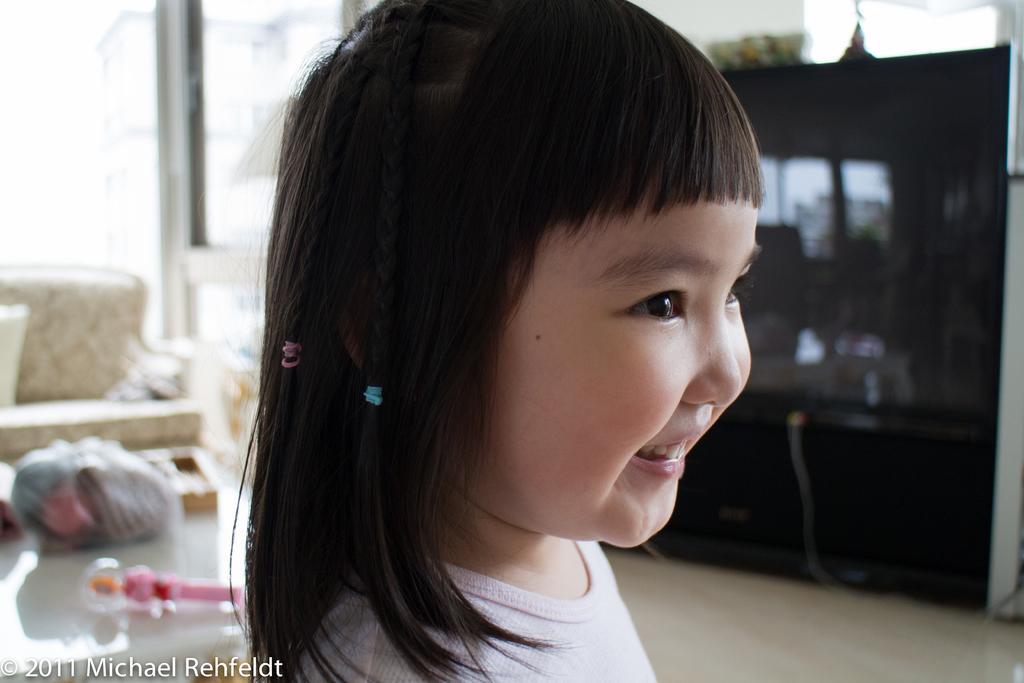Who is the main subject in the picture? There is a girl in the picture. Where is the girl located in the picture? The girl is in the middle of the picture. What expression does the girl have? The girl is smiling. What can be seen in the background of the picture? There is a sofa and a table in the background of the picture. What type of houses can be seen in the background of the picture? There are no houses visible in the background of the picture; it only shows a sofa and a table. 